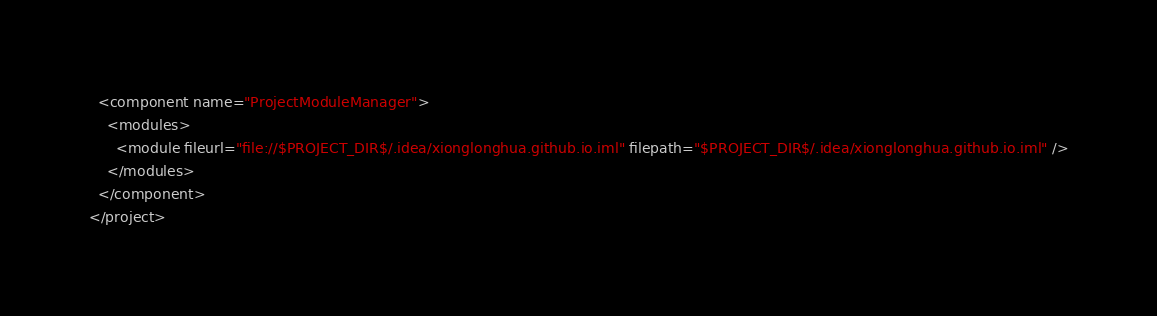<code> <loc_0><loc_0><loc_500><loc_500><_XML_>  <component name="ProjectModuleManager">
    <modules>
      <module fileurl="file://$PROJECT_DIR$/.idea/xionglonghua.github.io.iml" filepath="$PROJECT_DIR$/.idea/xionglonghua.github.io.iml" />
    </modules>
  </component>
</project></code> 